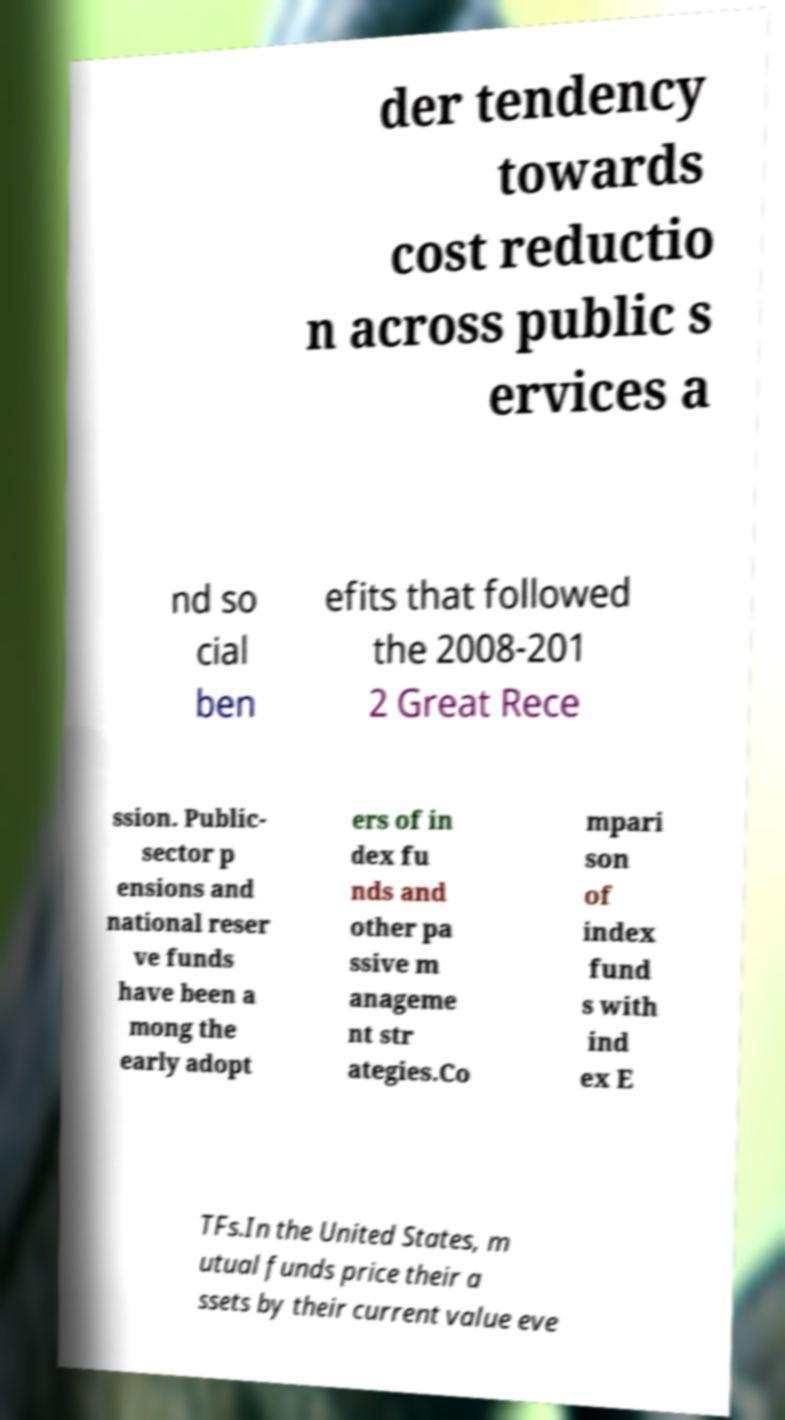I need the written content from this picture converted into text. Can you do that? der tendency towards cost reductio n across public s ervices a nd so cial ben efits that followed the 2008-201 2 Great Rece ssion. Public- sector p ensions and national reser ve funds have been a mong the early adopt ers of in dex fu nds and other pa ssive m anageme nt str ategies.Co mpari son of index fund s with ind ex E TFs.In the United States, m utual funds price their a ssets by their current value eve 